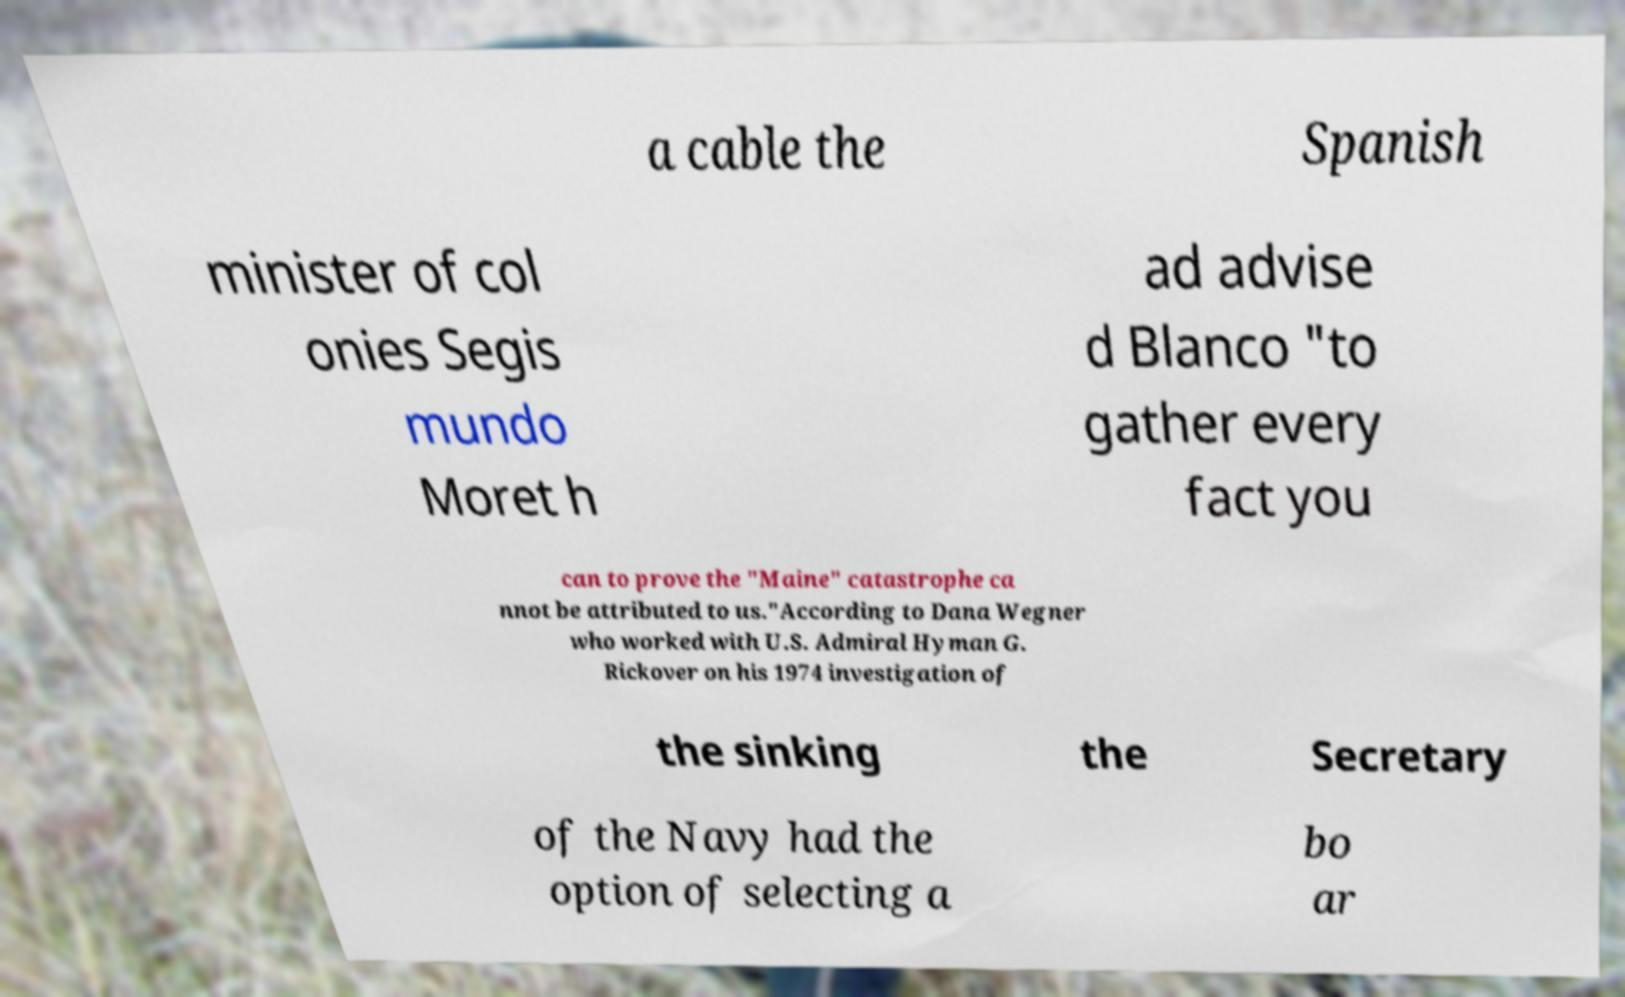Please identify and transcribe the text found in this image. a cable the Spanish minister of col onies Segis mundo Moret h ad advise d Blanco "to gather every fact you can to prove the "Maine" catastrophe ca nnot be attributed to us."According to Dana Wegner who worked with U.S. Admiral Hyman G. Rickover on his 1974 investigation of the sinking the Secretary of the Navy had the option of selecting a bo ar 